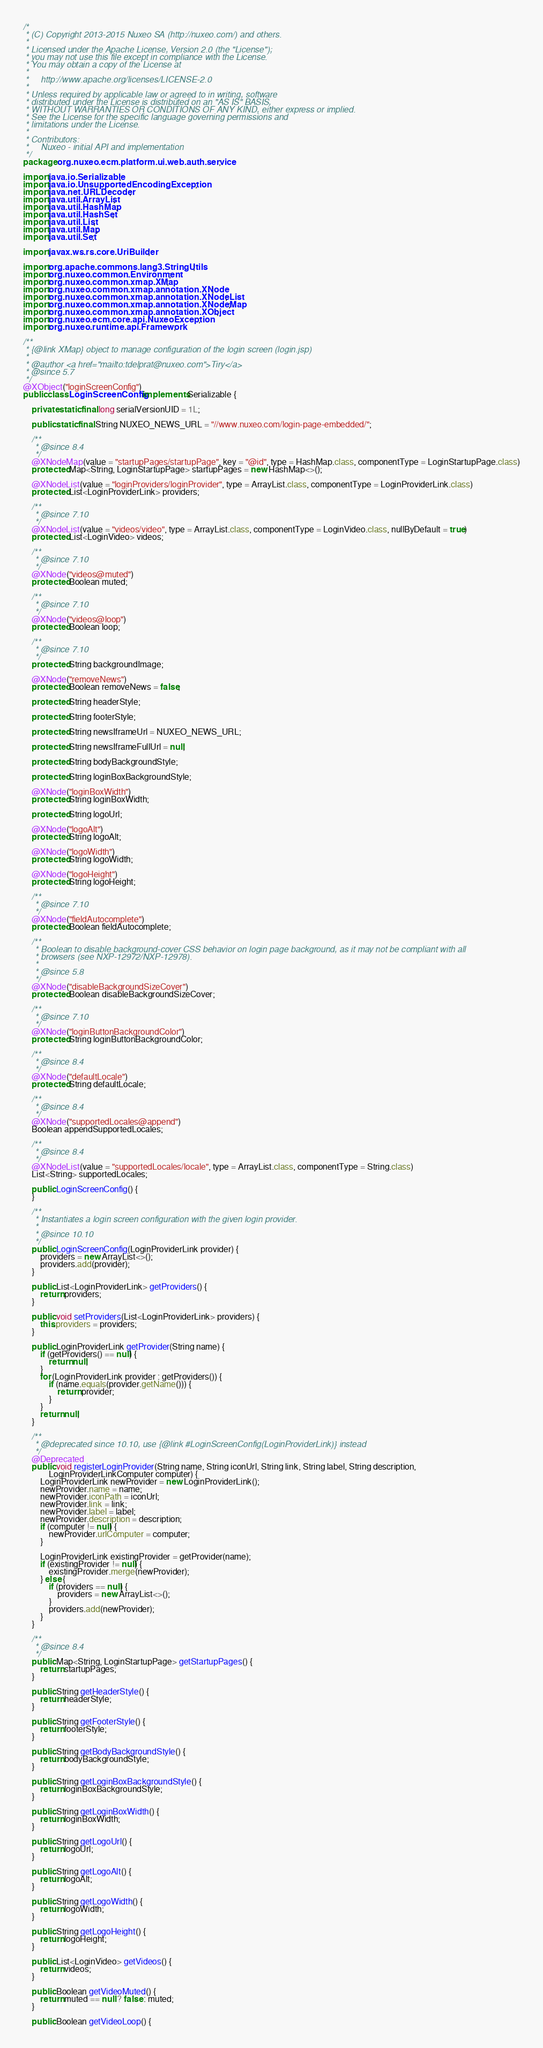Convert code to text. <code><loc_0><loc_0><loc_500><loc_500><_Java_>/*
 * (C) Copyright 2013-2015 Nuxeo SA (http://nuxeo.com/) and others.
 *
 * Licensed under the Apache License, Version 2.0 (the "License");
 * you may not use this file except in compliance with the License.
 * You may obtain a copy of the License at
 *
 *     http://www.apache.org/licenses/LICENSE-2.0
 *
 * Unless required by applicable law or agreed to in writing, software
 * distributed under the License is distributed on an "AS IS" BASIS,
 * WITHOUT WARRANTIES OR CONDITIONS OF ANY KIND, either express or implied.
 * See the License for the specific language governing permissions and
 * limitations under the License.
 *
 * Contributors:
 *     Nuxeo - initial API and implementation
 */
package org.nuxeo.ecm.platform.ui.web.auth.service;

import java.io.Serializable;
import java.io.UnsupportedEncodingException;
import java.net.URLDecoder;
import java.util.ArrayList;
import java.util.HashMap;
import java.util.HashSet;
import java.util.List;
import java.util.Map;
import java.util.Set;

import javax.ws.rs.core.UriBuilder;

import org.apache.commons.lang3.StringUtils;
import org.nuxeo.common.Environment;
import org.nuxeo.common.xmap.XMap;
import org.nuxeo.common.xmap.annotation.XNode;
import org.nuxeo.common.xmap.annotation.XNodeList;
import org.nuxeo.common.xmap.annotation.XNodeMap;
import org.nuxeo.common.xmap.annotation.XObject;
import org.nuxeo.ecm.core.api.NuxeoException;
import org.nuxeo.runtime.api.Framework;

/**
 * {@link XMap} object to manage configuration of the login screen (login.jsp)
 *
 * @author <a href="mailto:tdelprat@nuxeo.com">Tiry</a>
 * @since 5.7
 */
@XObject("loginScreenConfig")
public class LoginScreenConfig implements Serializable {

    private static final long serialVersionUID = 1L;

    public static final String NUXEO_NEWS_URL = "//www.nuxeo.com/login-page-embedded/";

    /**
     * @since 8.4
     */
    @XNodeMap(value = "startupPages/startupPage", key = "@id", type = HashMap.class, componentType = LoginStartupPage.class)
    protected Map<String, LoginStartupPage> startupPages = new HashMap<>();

    @XNodeList(value = "loginProviders/loginProvider", type = ArrayList.class, componentType = LoginProviderLink.class)
    protected List<LoginProviderLink> providers;

    /**
     * @since 7.10
     */
    @XNodeList(value = "videos/video", type = ArrayList.class, componentType = LoginVideo.class, nullByDefault = true)
    protected List<LoginVideo> videos;

    /**
     * @since 7.10
     */
    @XNode("videos@muted")
    protected Boolean muted;

    /**
     * @since 7.10
     */
    @XNode("videos@loop")
    protected Boolean loop;

    /**
     * @since 7.10
     */
    protected String backgroundImage;

    @XNode("removeNews")
    protected Boolean removeNews = false;

    protected String headerStyle;

    protected String footerStyle;

    protected String newsIframeUrl = NUXEO_NEWS_URL;

    protected String newsIframeFullUrl = null;

    protected String bodyBackgroundStyle;

    protected String loginBoxBackgroundStyle;

    @XNode("loginBoxWidth")
    protected String loginBoxWidth;

    protected String logoUrl;

    @XNode("logoAlt")
    protected String logoAlt;

    @XNode("logoWidth")
    protected String logoWidth;

    @XNode("logoHeight")
    protected String logoHeight;

    /**
     * @since 7.10
     */
    @XNode("fieldAutocomplete")
    protected Boolean fieldAutocomplete;

    /**
     * Boolean to disable background-cover CSS behavior on login page background, as it may not be compliant with all
     * browsers (see NXP-12972/NXP-12978).
     *
     * @since 5.8
     */
    @XNode("disableBackgroundSizeCover")
    protected Boolean disableBackgroundSizeCover;

    /**
     * @since 7.10
     */
    @XNode("loginButtonBackgroundColor")
    protected String loginButtonBackgroundColor;

    /**
     * @since 8.4
     */
    @XNode("defaultLocale")
    protected String defaultLocale;

    /**
     * @since 8.4
     */
    @XNode("supportedLocales@append")
    Boolean appendSupportedLocales;

    /**
     * @since 8.4
     */
    @XNodeList(value = "supportedLocales/locale", type = ArrayList.class, componentType = String.class)
    List<String> supportedLocales;

    public LoginScreenConfig() {
    }

    /**
     * Instantiates a login screen configuration with the given login provider.
     *
     * @since 10.10
     */
    public LoginScreenConfig(LoginProviderLink provider) {
        providers = new ArrayList<>();
        providers.add(provider);
    }

    public List<LoginProviderLink> getProviders() {
        return providers;
    }

    public void setProviders(List<LoginProviderLink> providers) {
        this.providers = providers;
    }

    public LoginProviderLink getProvider(String name) {
        if (getProviders() == null) {
            return null;
        }
        for (LoginProviderLink provider : getProviders()) {
            if (name.equals(provider.getName())) {
                return provider;
            }
        }
        return null;
    }

    /**
     * @deprecated since 10.10, use {@link #LoginScreenConfig(LoginProviderLink)} instead
     */
    @Deprecated
    public void registerLoginProvider(String name, String iconUrl, String link, String label, String description,
            LoginProviderLinkComputer computer) {
        LoginProviderLink newProvider = new LoginProviderLink();
        newProvider.name = name;
        newProvider.iconPath = iconUrl;
        newProvider.link = link;
        newProvider.label = label;
        newProvider.description = description;
        if (computer != null) {
            newProvider.urlComputer = computer;
        }

        LoginProviderLink existingProvider = getProvider(name);
        if (existingProvider != null) {
            existingProvider.merge(newProvider);
        } else {
            if (providers == null) {
                providers = new ArrayList<>();
            }
            providers.add(newProvider);
        }
    }

    /**
     * @since 8.4
     */
    public Map<String, LoginStartupPage> getStartupPages() {
        return startupPages;
    }

    public String getHeaderStyle() {
        return headerStyle;
    }

    public String getFooterStyle() {
        return footerStyle;
    }

    public String getBodyBackgroundStyle() {
        return bodyBackgroundStyle;
    }

    public String getLoginBoxBackgroundStyle() {
        return loginBoxBackgroundStyle;
    }

    public String getLoginBoxWidth() {
        return loginBoxWidth;
    }

    public String getLogoUrl() {
        return logoUrl;
    }

    public String getLogoAlt() {
        return logoAlt;
    }

    public String getLogoWidth() {
        return logoWidth;
    }

    public String getLogoHeight() {
        return logoHeight;
    }

    public List<LoginVideo> getVideos() {
        return videos;
    }

    public Boolean getVideoMuted() {
        return muted == null ? false : muted;
    }

    public Boolean getVideoLoop() {</code> 